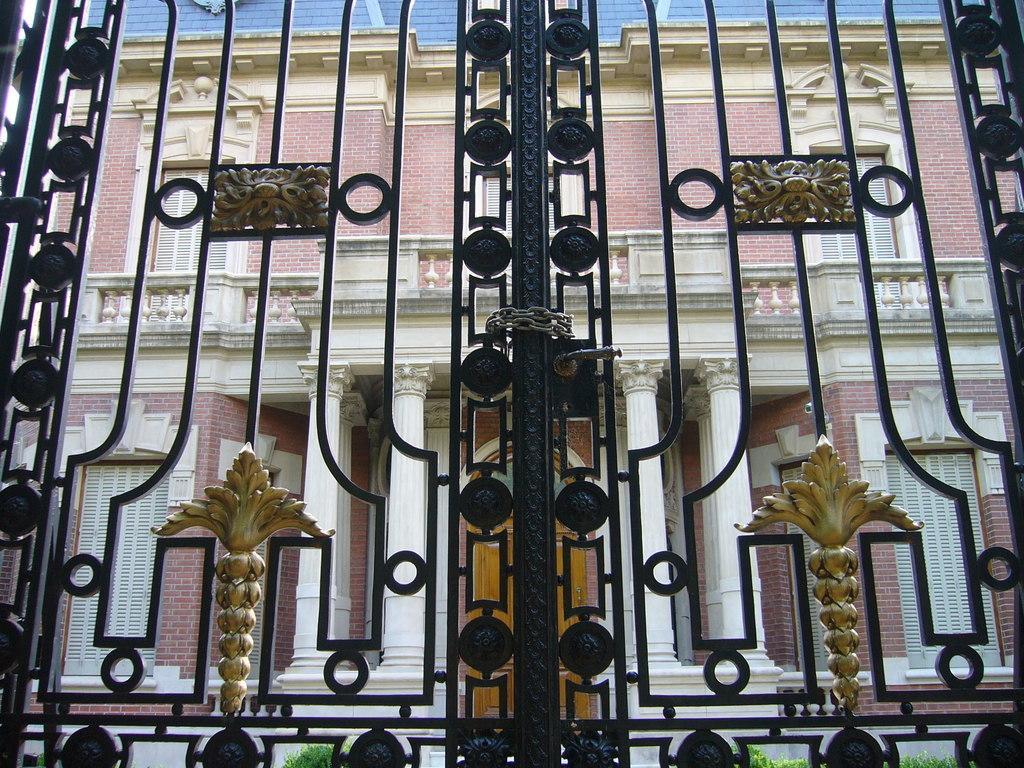Describe this image in one or two sentences. In the foreground, I can see a black color gate. In the background there is a building. 